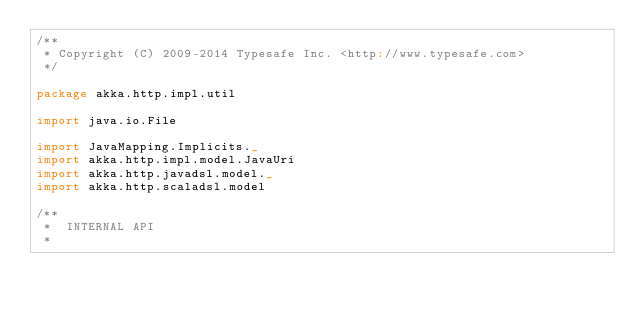Convert code to text. <code><loc_0><loc_0><loc_500><loc_500><_Scala_>/**
 * Copyright (C) 2009-2014 Typesafe Inc. <http://www.typesafe.com>
 */

package akka.http.impl.util

import java.io.File

import JavaMapping.Implicits._
import akka.http.impl.model.JavaUri
import akka.http.javadsl.model._
import akka.http.scaladsl.model

/**
 *  INTERNAL API
 *</code> 